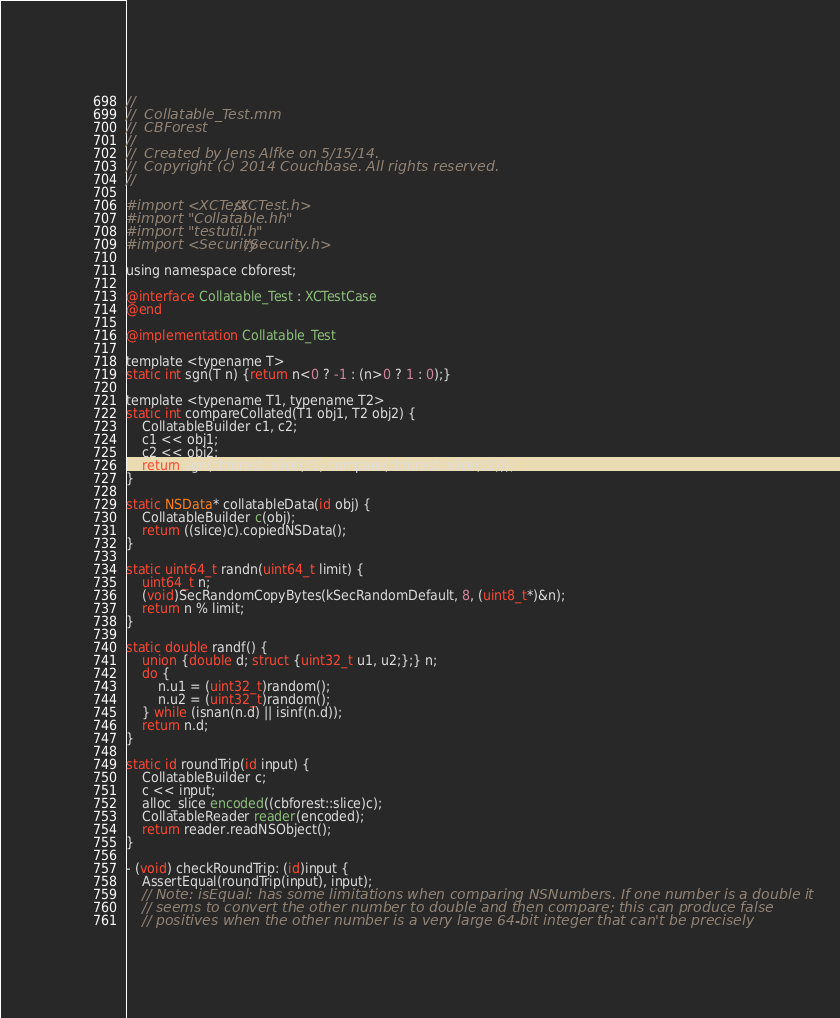Convert code to text. <code><loc_0><loc_0><loc_500><loc_500><_ObjectiveC_>//
//  Collatable_Test.mm
//  CBForest
//
//  Created by Jens Alfke on 5/15/14.
//  Copyright (c) 2014 Couchbase. All rights reserved.
//

#import <XCTest/XCTest.h>
#import "Collatable.hh"
#import "testutil.h"
#import <Security/Security.h>

using namespace cbforest;

@interface Collatable_Test : XCTestCase
@end

@implementation Collatable_Test

template <typename T>
static int sgn(T n) {return n<0 ? -1 : (n>0 ? 1 : 0);}

template <typename T1, typename T2>
static int compareCollated(T1 obj1, T2 obj2) {
    CollatableBuilder c1, c2;
    c1 << obj1;
    c2 << obj2;
    return sgn(cbforest::slice(c1).compare(cbforest::slice(c2)));
}

static NSData* collatableData(id obj) {
    CollatableBuilder c(obj);
    return ((slice)c).copiedNSData();
}

static uint64_t randn(uint64_t limit) {
    uint64_t n;
    (void)SecRandomCopyBytes(kSecRandomDefault, 8, (uint8_t*)&n);
    return n % limit;
}

static double randf() {
    union {double d; struct {uint32_t u1, u2;};} n;
    do {
        n.u1 = (uint32_t)random();
        n.u2 = (uint32_t)random();
    } while (isnan(n.d) || isinf(n.d));
    return n.d;
}

static id roundTrip(id input) {
    CollatableBuilder c;
    c << input;
    alloc_slice encoded((cbforest::slice)c);
    CollatableReader reader(encoded);
    return reader.readNSObject();
}

- (void) checkRoundTrip: (id)input {
    AssertEqual(roundTrip(input), input);
    // Note: isEqual: has some limitations when comparing NSNumbers. If one number is a double it
    // seems to convert the other number to double and then compare; this can produce false
    // positives when the other number is a very large 64-bit integer that can't be precisely</code> 